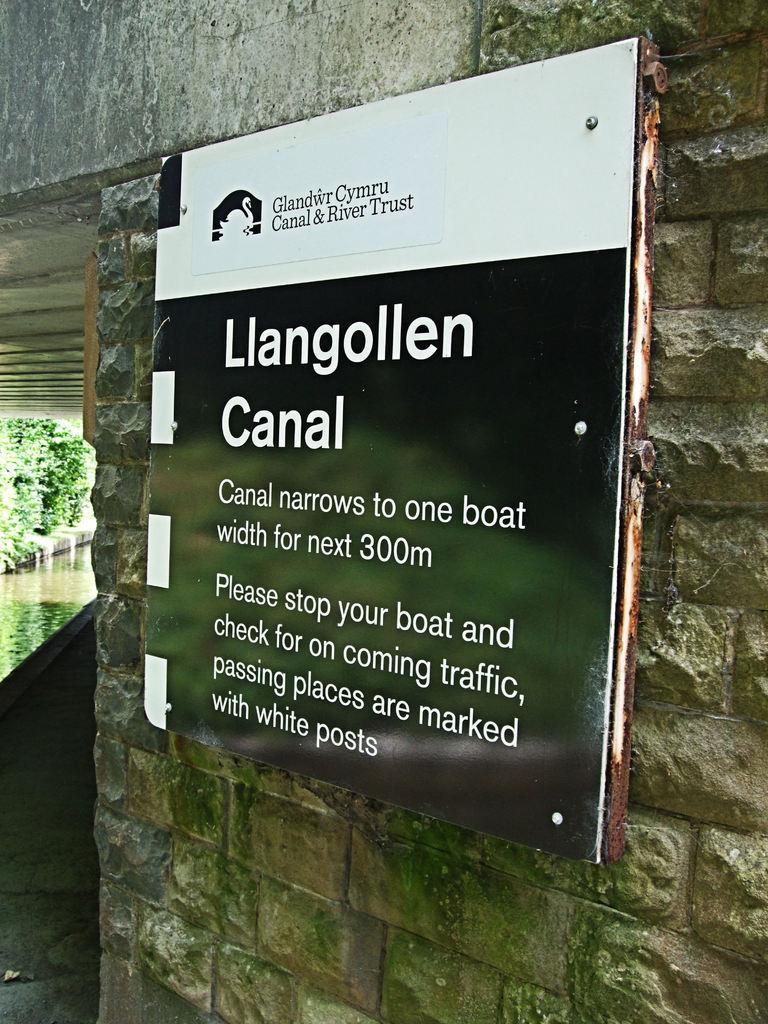Please provide a concise description of this image. In this picture we can see the banner board placed on the wall. 